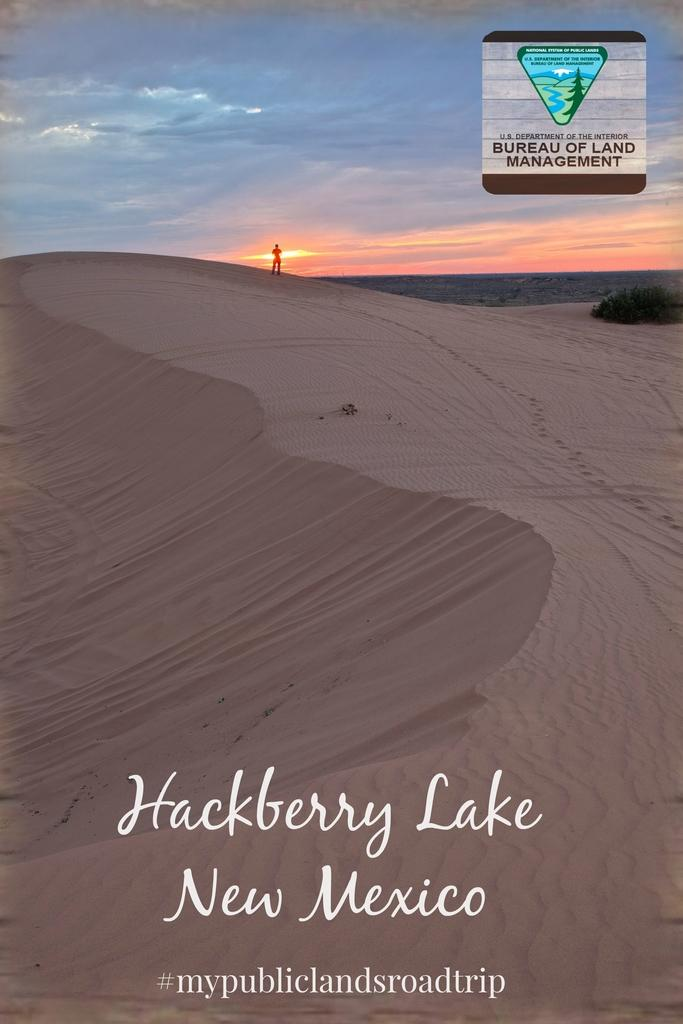<image>
Summarize the visual content of the image. a New Mexico ad with sand from some company 